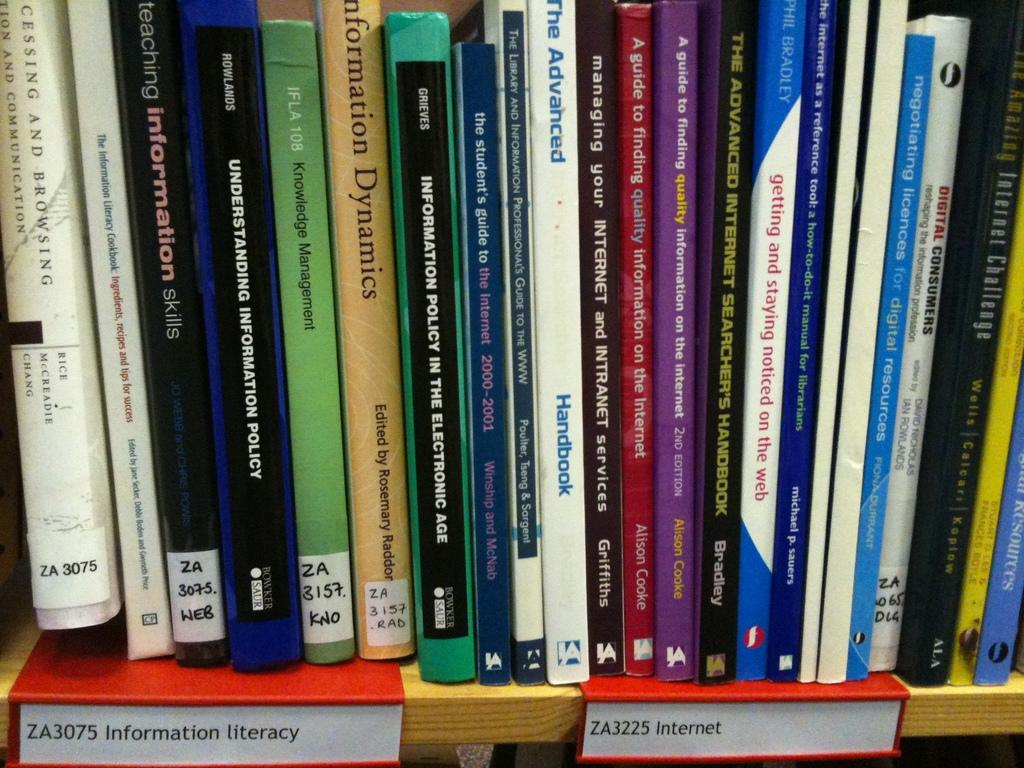What objects are present in the image? There are books in the image. Where are the books located? The books are in a bookshelf. What additional feature can be seen at the bottom of the bookshelf? There are name plates at the bottom of the bookshelf. What type of leather material is used to cover the art pieces in the image? There are no art pieces or leather materials present in the image; it features books in a bookshelf with name plates. 